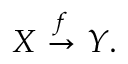Convert formula to latex. <formula><loc_0><loc_0><loc_500><loc_500>X { \stackrel { f } { \to } } Y .</formula> 